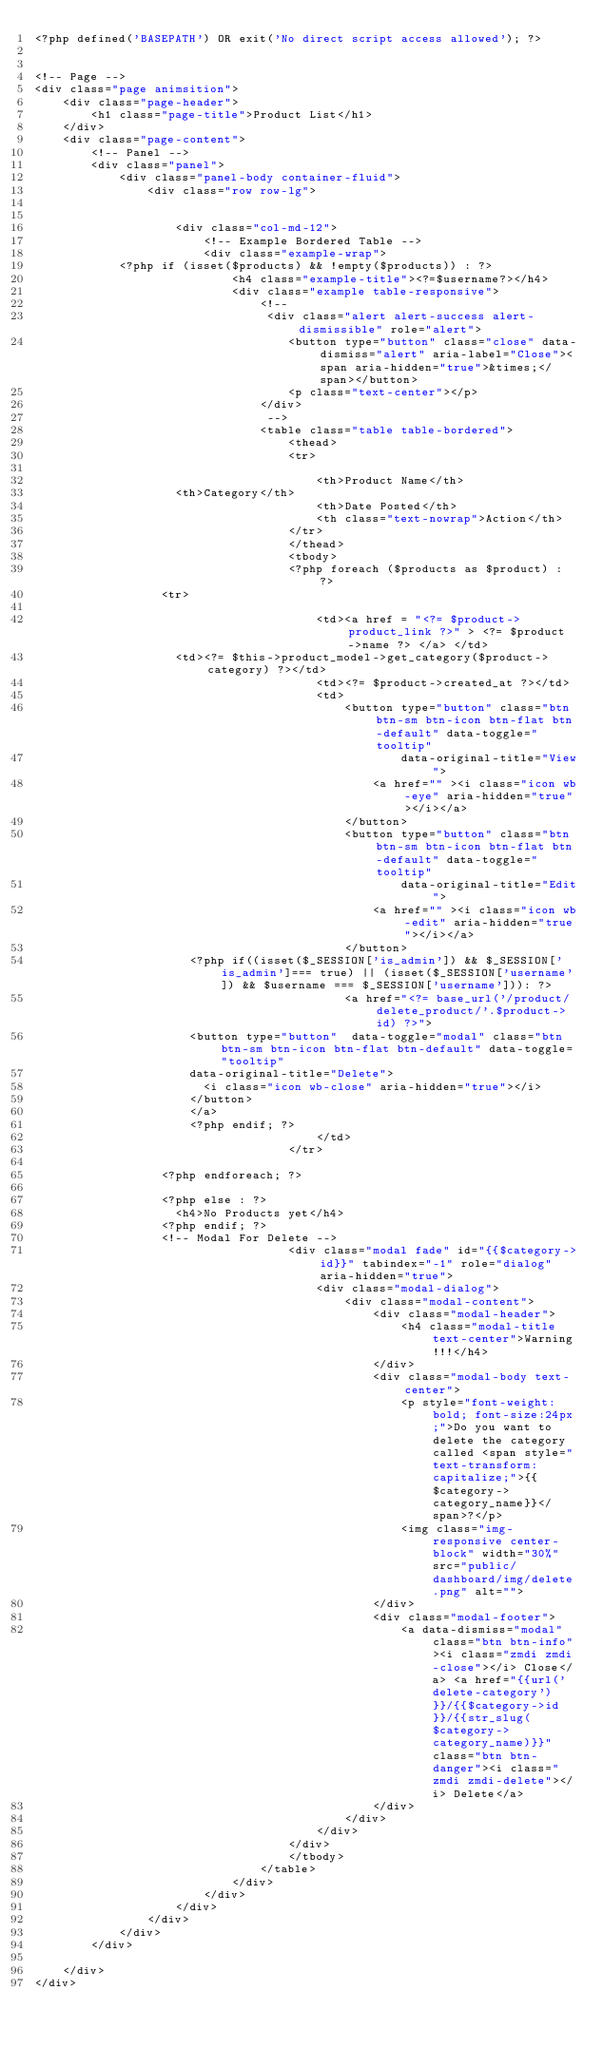Convert code to text. <code><loc_0><loc_0><loc_500><loc_500><_PHP_><?php defined('BASEPATH') OR exit('No direct script access allowed'); ?>


<!-- Page -->
<div class="page animsition">
    <div class="page-header">
        <h1 class="page-title">Product List</h1>
    </div>
    <div class="page-content">
        <!-- Panel -->
        <div class="panel">
            <div class="panel-body container-fluid">
                <div class="row row-lg">


                    <div class="col-md-12">
                        <!-- Example Bordered Table -->
                        <div class="example-wrap">
						<?php if (isset($products) && !empty($products)) : ?>
                            <h4 class="example-title"><?=$username?></h4>
                            <div class="example table-responsive">
                                <!--
                                 <div class="alert alert-success alert-dismissible" role="alert">
                                    <button type="button" class="close" data-dismiss="alert" aria-label="Close"><span aria-hidden="true">&times;</span></button>
                                    <p class="text-center"></p>
                                </div>
                                 -->
                                <table class="table table-bordered">
                                    <thead>
                                    <tr>
                                        
                                        <th>Product Name</th>
										<th>Category</th>
                                        <th>Date Posted</th>
                                        <th class="text-nowrap">Action</th>
                                    </tr>
                                    </thead>
                                    <tbody>
                                    <?php foreach ($products as $product) : ?>
									<tr>
                                        
                                        <td><a href = "<?= $product->product_link ?>" > <?= $product->name ?> </a> </td>
										<td><?= $this->product_model->get_category($product->category) ?></td>
                                        <td><?= $product->created_at ?></td>
                                        <td>
                                            <button type="button" class="btn btn-sm btn-icon btn-flat btn-default" data-toggle="tooltip"
                                                    data-original-title="View">
                                                <a href="" ><i class="icon wb-eye" aria-hidden="true"></i></a>
                                            </button>
                                            <button type="button" class="btn btn-sm btn-icon btn-flat btn-default" data-toggle="tooltip"
                                                    data-original-title="Edit">
                                                <a href="" ><i class="icon wb-edit" aria-hidden="true"></i></a>
                                            </button>
											<?php if((isset($_SESSION['is_admin']) && $_SESSION['is_admin']=== true) || (isset($_SESSION['username']) && $username === $_SESSION['username'])): ?>
                                            <a href="<?= base_url('/product/delete_product/'.$product->id) ?>">
											<button type="button"  data-toggle="modal" class="btn btn-sm btn-icon btn-flat btn-default" data-toggle="tooltip"
											data-original-title="Delete">
												<i class="icon wb-close" aria-hidden="true"></i>
											</button>
											</a>
											<?php endif; ?>
                                        </td>
                                    </tr>
                                    
									<?php endforeach; ?>
									
									<?php else : ?>
										<h4>No Products yet</h4>
									<?php endif; ?>
									<!-- Modal For Delete -->
                                    <div class="modal fade" id="{{$category->id}}" tabindex="-1" role="dialog" aria-hidden="true">
                                        <div class="modal-dialog">
                                            <div class="modal-content">
                                                <div class="modal-header">
                                                    <h4 class="modal-title text-center">Warning!!!</h4>
                                                </div>
                                                <div class="modal-body text-center">
                                                    <p style="font-weight: bold; font-size:24px;">Do you want to delete the category called <span style="text-transform: capitalize;">{{$category->category_name}}</span>?</p>
                                                    <img class="img-responsive center-block" width="30%" src="public/dashboard/img/delete.png" alt="">
                                                </div>
                                                <div class="modal-footer">
                                                    <a data-dismiss="modal" class="btn btn-info"><i class="zmdi zmdi-close"></i> Close</a> <a href="{{url('delete-category')}}/{{$category->id}}/{{str_slug($category->category_name)}}" class="btn btn-danger"><i class="zmdi zmdi-delete"></i> Delete</a>
                                                </div>
                                            </div>
                                        </div>
                                    </div>
                                    </tbody>
                                </table>
                            </div>
                        </div>
                    </div>
                </div>
            </div>
        </div>

    </div>
</div>
</code> 